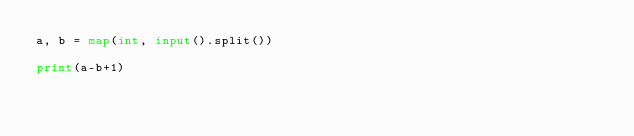<code> <loc_0><loc_0><loc_500><loc_500><_Python_>a, b = map(int, input().split())

print(a-b+1)</code> 